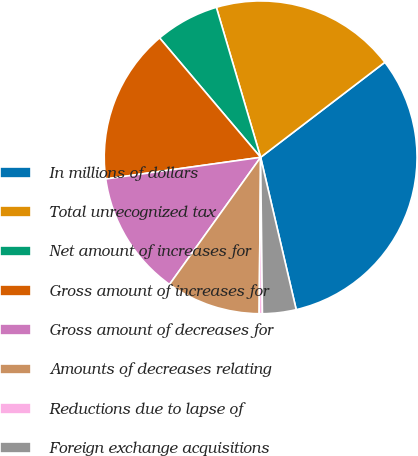<chart> <loc_0><loc_0><loc_500><loc_500><pie_chart><fcel>In millions of dollars<fcel>Total unrecognized tax<fcel>Net amount of increases for<fcel>Gross amount of increases for<fcel>Gross amount of decreases for<fcel>Amounts of decreases relating<fcel>Reductions due to lapse of<fcel>Foreign exchange acquisitions<nl><fcel>31.74%<fcel>19.17%<fcel>6.61%<fcel>16.03%<fcel>12.89%<fcel>9.75%<fcel>0.33%<fcel>3.47%<nl></chart> 